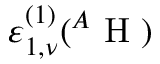<formula> <loc_0><loc_0><loc_500><loc_500>\varepsilon _ { 1 , \nu } ^ { ( 1 ) } ^ { A } H )</formula> 